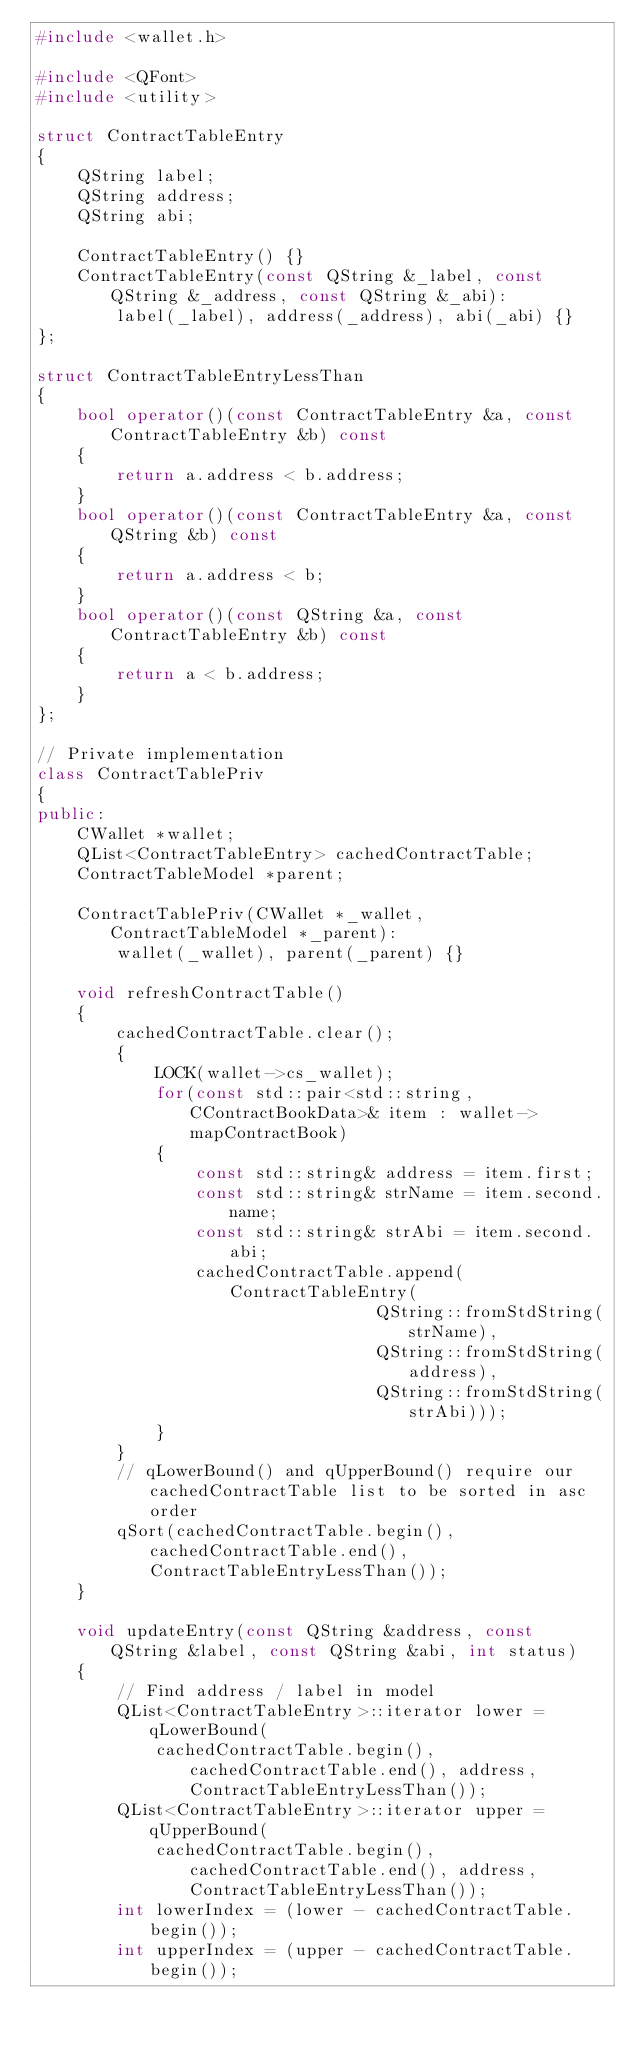Convert code to text. <code><loc_0><loc_0><loc_500><loc_500><_C++_>#include <wallet.h>

#include <QFont>
#include <utility>

struct ContractTableEntry
{
    QString label;
    QString address;
    QString abi;

    ContractTableEntry() {}
    ContractTableEntry(const QString &_label, const QString &_address, const QString &_abi):
        label(_label), address(_address), abi(_abi) {}
};

struct ContractTableEntryLessThan
{
    bool operator()(const ContractTableEntry &a, const ContractTableEntry &b) const
    {
        return a.address < b.address;
    }
    bool operator()(const ContractTableEntry &a, const QString &b) const
    {
        return a.address < b;
    }
    bool operator()(const QString &a, const ContractTableEntry &b) const
    {
        return a < b.address;
    }
};

// Private implementation
class ContractTablePriv
{
public:
    CWallet *wallet;
    QList<ContractTableEntry> cachedContractTable;
    ContractTableModel *parent;

    ContractTablePriv(CWallet *_wallet, ContractTableModel *_parent):
        wallet(_wallet), parent(_parent) {}

    void refreshContractTable()
    {
        cachedContractTable.clear();
        {
            LOCK(wallet->cs_wallet);
            for(const std::pair<std::string, CContractBookData>& item : wallet->mapContractBook)
            {
                const std::string& address = item.first;
                const std::string& strName = item.second.name;
                const std::string& strAbi = item.second.abi;
                cachedContractTable.append(ContractTableEntry(
                                  QString::fromStdString(strName),
                                  QString::fromStdString(address),
                                  QString::fromStdString(strAbi)));
            }
        }
        // qLowerBound() and qUpperBound() require our cachedContractTable list to be sorted in asc order
        qSort(cachedContractTable.begin(), cachedContractTable.end(), ContractTableEntryLessThan());
    }

    void updateEntry(const QString &address, const QString &label, const QString &abi, int status)
    {
        // Find address / label in model
        QList<ContractTableEntry>::iterator lower = qLowerBound(
            cachedContractTable.begin(), cachedContractTable.end(), address, ContractTableEntryLessThan());
        QList<ContractTableEntry>::iterator upper = qUpperBound(
            cachedContractTable.begin(), cachedContractTable.end(), address, ContractTableEntryLessThan());
        int lowerIndex = (lower - cachedContractTable.begin());
        int upperIndex = (upper - cachedContractTable.begin());</code> 